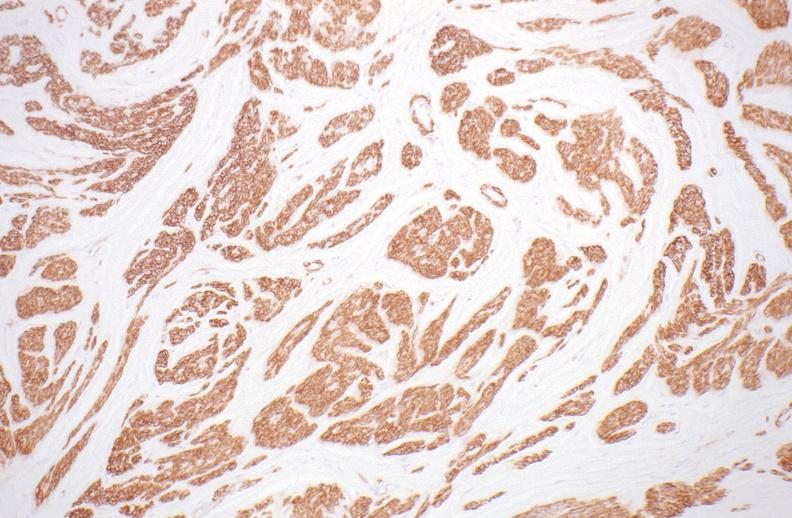what is present?
Answer the question using a single word or phrase. Female reproductive 